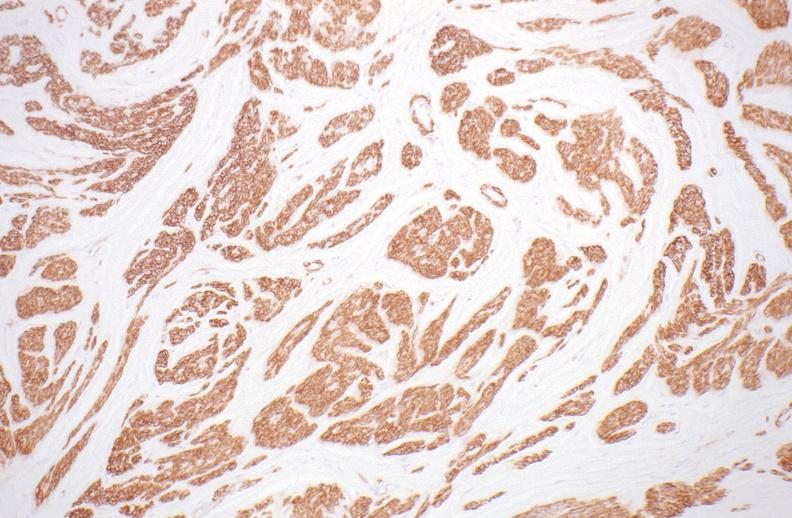what is present?
Answer the question using a single word or phrase. Female reproductive 